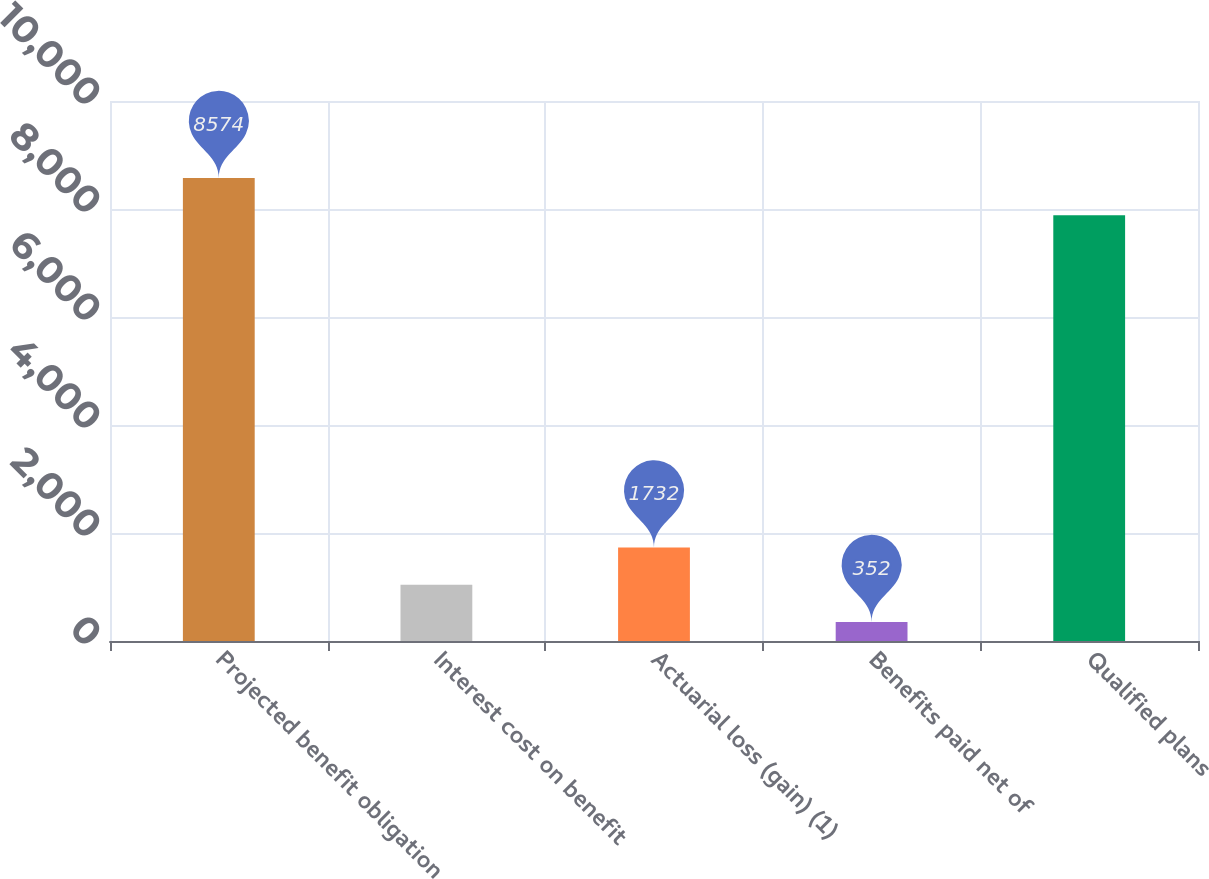Convert chart. <chart><loc_0><loc_0><loc_500><loc_500><bar_chart><fcel>Projected benefit obligation<fcel>Interest cost on benefit<fcel>Actuarial loss (gain) (1)<fcel>Benefits paid net of<fcel>Qualified plans<nl><fcel>8574<fcel>1042<fcel>1732<fcel>352<fcel>7884<nl></chart> 